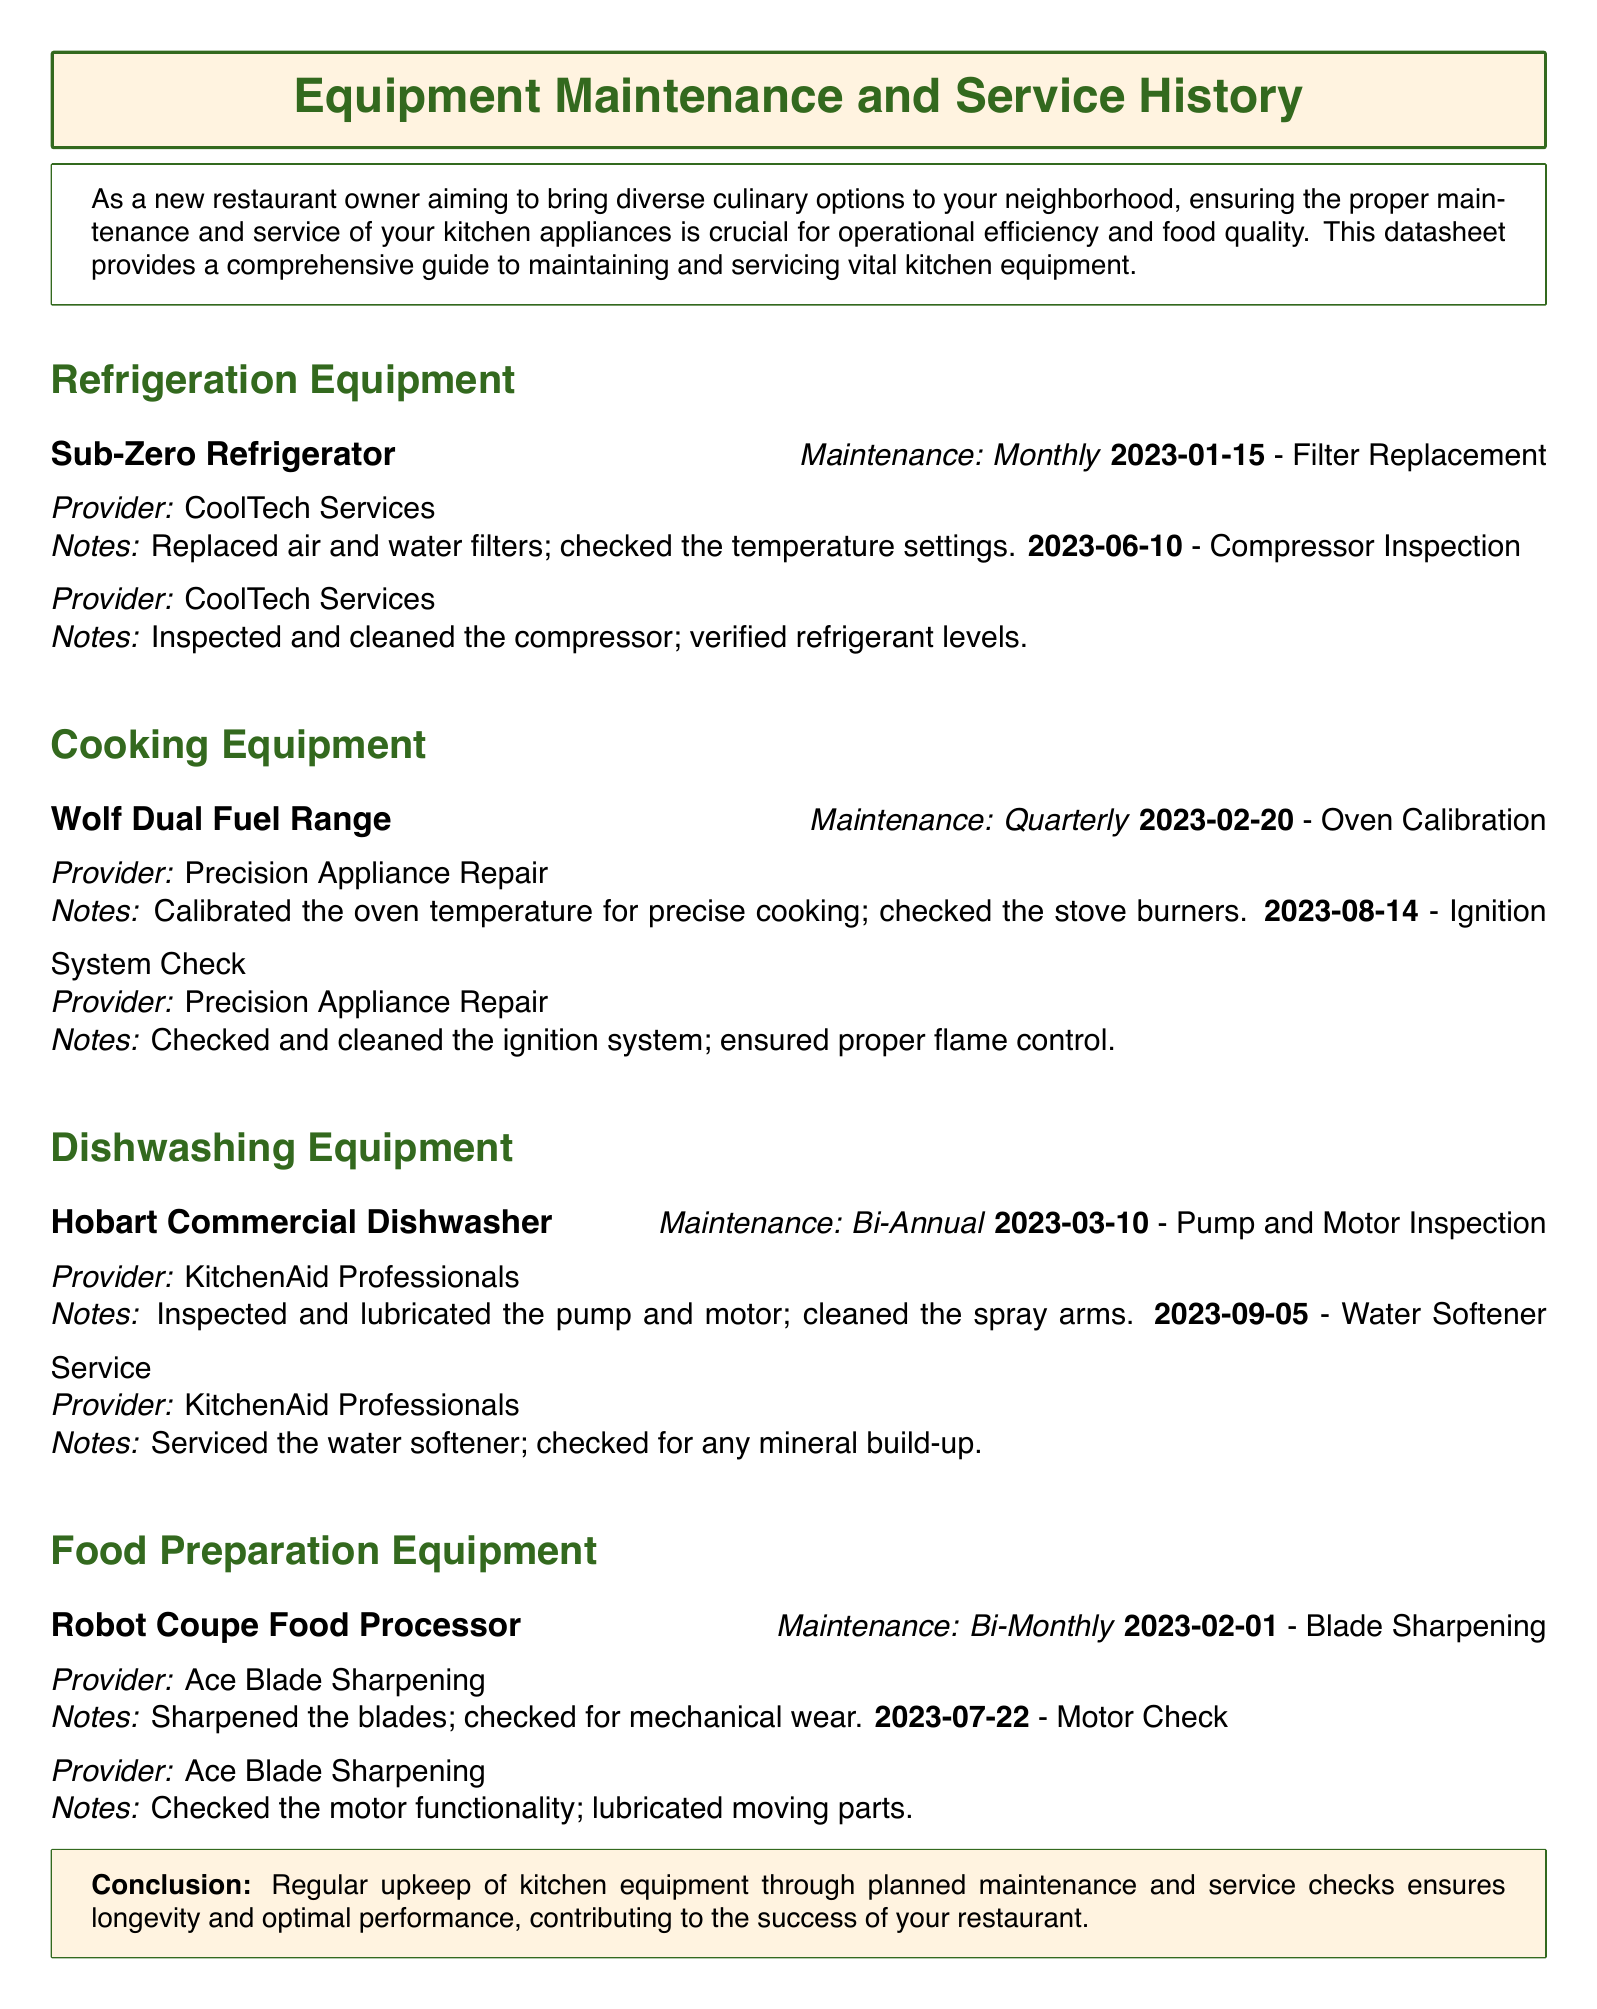what is the maintenance frequency for the Sub-Zero Refrigerator? The maintenance frequency for the Sub-Zero Refrigerator is stated as monthly in the document.
Answer: Monthly when was the last service for the Wolf Dual Fuel Range? The last service date for the Wolf Dual Fuel Range is provided as August 14, 2023.
Answer: August 14, 2023 how often is the Hobart Commercial Dishwasher serviced? The document mentions that the Hobart Commercial Dishwasher is serviced bi-annually.
Answer: Bi-Annual who serviced the Robot Coupe Food Processor on July 22, 2023? The service on July 22, 2023, for the Robot Coupe Food Processor was conducted by Ace Blade Sharpening according to the document.
Answer: Ace Blade Sharpening what type of inspection was performed on the Sub-Zero Refrigerator on January 15, 2023? The inspection performed on January 15, 2023, for the Sub-Zero Refrigerator was a filter replacement.
Answer: Filter Replacement how many services were listed for the Hobart Commercial Dishwasher? The document includes two services listed for the Hobart Commercial Dishwasher.
Answer: Two what justification does the document provide for regular equipment maintenance? The document states that regular upkeep ensures longevity and optimal performance, contributing to restaurant success.
Answer: Ensures longevity and optimal performance what is the main purpose of the datasheet? The datasheet aims to provide guidelines for maintaining and servicing kitchen equipment effectively.
Answer: Guidelines for maintenance and servicing 